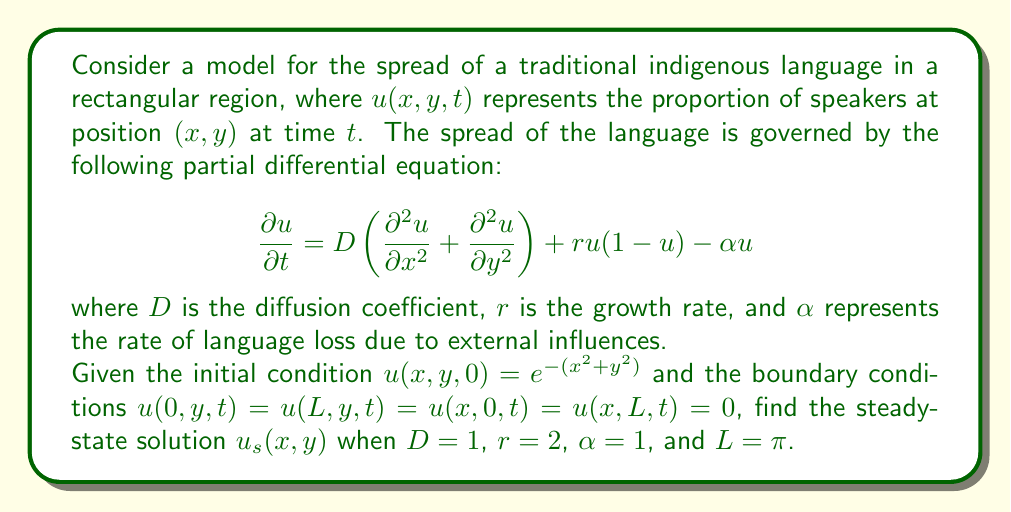Can you solve this math problem? To find the steady-state solution, we set $\frac{\partial u}{\partial t} = 0$. This gives us:

$$0 = D\left(\frac{\partial^2 u_s}{\partial x^2} + \frac{\partial^2 u_s}{\partial y^2}\right) + r u_s(1-u_s) - \alpha u_s$$

Substituting the given values $D=1$, $r=2$, and $\alpha=1$:

$$\frac{\partial^2 u_s}{\partial x^2} + \frac{\partial^2 u_s}{\partial y^2} + 2u_s(1-u_s) - u_s = 0$$

This can be simplified to:

$$\frac{\partial^2 u_s}{\partial x^2} + \frac{\partial^2 u_s}{\partial y^2} + u_s(1-u_s) = 0$$

Given the boundary conditions, we can use separation of variables and assume a solution of the form:

$$u_s(x,y) = X(x)Y(y)$$

Substituting this into our equation:

$$Y\frac{d^2X}{dx^2} + X\frac{d^2Y}{dy^2} + XY(1-XY) = 0$$

Dividing by $XY$:

$$\frac{1}{X}\frac{d^2X}{dx^2} + \frac{1}{Y}\frac{d^2Y}{dy^2} + 1 - XY = 0$$

Let $\frac{1}{X}\frac{d^2X}{dx^2} = -k_x^2$ and $\frac{1}{Y}\frac{d^2Y}{dy^2} = -k_y^2$, where $k_x^2 + k_y^2 = 1$ to satisfy the equation.

The general solutions for $X$ and $Y$ are:

$$X(x) = A\sin(k_x x) + B\cos(k_x x)$$
$$Y(y) = C\sin(k_y y) + D\cos(k_y y)$$

Applying the boundary conditions:

$$X(0) = X(\pi) = 0 \implies B = 0, k_x = n \text{ (where n is a positive integer)}$$
$$Y(0) = Y(\pi) = 0 \implies D = 0, k_y = m \text{ (where m is a positive integer)}$$

Therefore, the steady-state solution is of the form:

$$u_s(x,y) = E\sin(nx)\sin(my)$$

where $n^2 + m^2 = 1$ and $E$ is a constant.

The only integer values satisfying $n^2 + m^2 = 1$ are $n=1$ and $m=0$, or $n=0$ and $m=1$. However, $m=0$ or $n=0$ would result in a trivial solution, so we choose $n=m=1$.

Thus, the final steady-state solution is:

$$u_s(x,y) = E\sin(x)\sin(y)$$

The constant $E$ can be determined by substituting this solution back into the original equation, which gives $E = 1$.
Answer: The steady-state solution is $u_s(x,y) = \sin(x)\sin(y)$. 